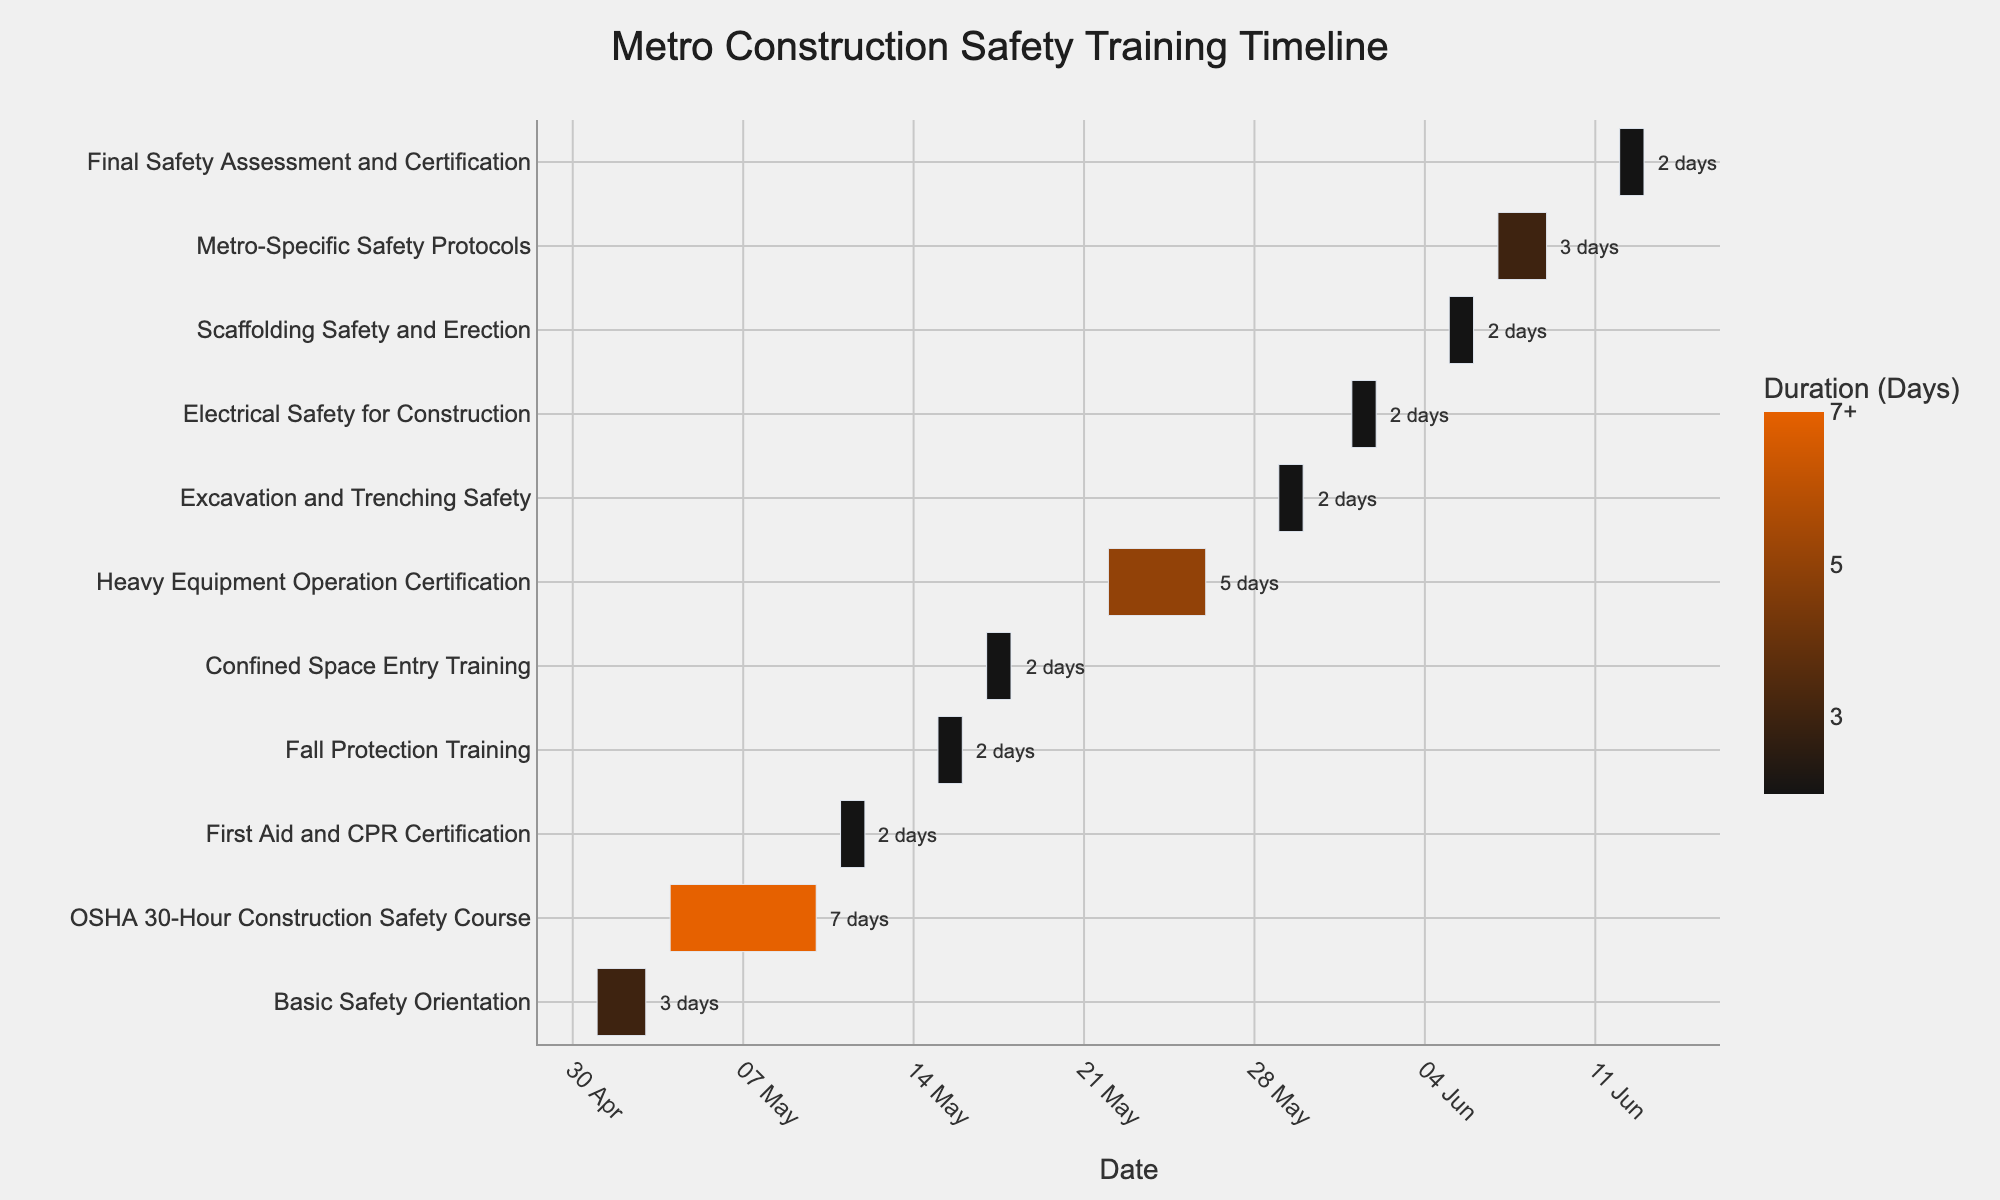What's the title of the figure? The title of the figure is usually displayed prominently at the top of the chart.
Answer: Metro Construction Safety Training Timeline When does the Basic Safety Orientation begin and end? The Basic Safety Orientation is marked on the figure starting at 2023-05-01 and ending on 2023-05-03.
Answer: 2023-05-01 to 2023-05-03 Which training module takes the longest duration? By observing the color gradients and annotations of the tasks, the Heavy Equipment Operation Certification spans 5 days, the longest among all tasks.
Answer: Heavy Equipment Operation Certification How many training modules are scheduled for June? Modules occurring in June include Electrical Safety for Construction, Scaffolding Safety and Erection, Metro-Specific Safety Protocols, and Final Safety Assessment and Certification. Count these modules.
Answer: 4 What is the total duration for all training modules combined? Sum the durations of all individual training modules as annotated on the chart: 3 + 7 + 2 + 2 + 2 + 5 + 2 + 2 + 2 + 3 + 2.
Answer: 32 days Which training module ends on 2023-05-10? Check the end dates for each module; the OSHA 30-Hour Construction Safety Course completes on this date.
Answer: OSHA 30-Hour Construction Safety Course Which training takes place immediately after Fall Protection Training? Identify the training following Fall Protection Training based on their start dates. Confined Space Entry Training starts immediately after it.
Answer: Confined Space Entry Training Compare the durations of Excavation and Trenching Safety with Electrical Safety for Construction. Which one is longer? Both training modules are annotated with their duration. Compare 2 days for Excavation and Trenching Safety with 2 days for Electrical Safety for Construction.
Answer: Same duration What's the duration of training needed for certification after completing OSHA 30-Hour Construction Safety Course? Sum the durations of all subsequent tasks from May 11 onwards: 2 + 2 + 2 + 5 + 2 + 2 + 2 + 3 + 2.
Answer: 22 days How many days of training are scheduled before the first module in June? Sum the durations of all modules scheduled in May: 3 + 7 + 2 + 2 + 2 + 5 + 2.
Answer: 23 days 